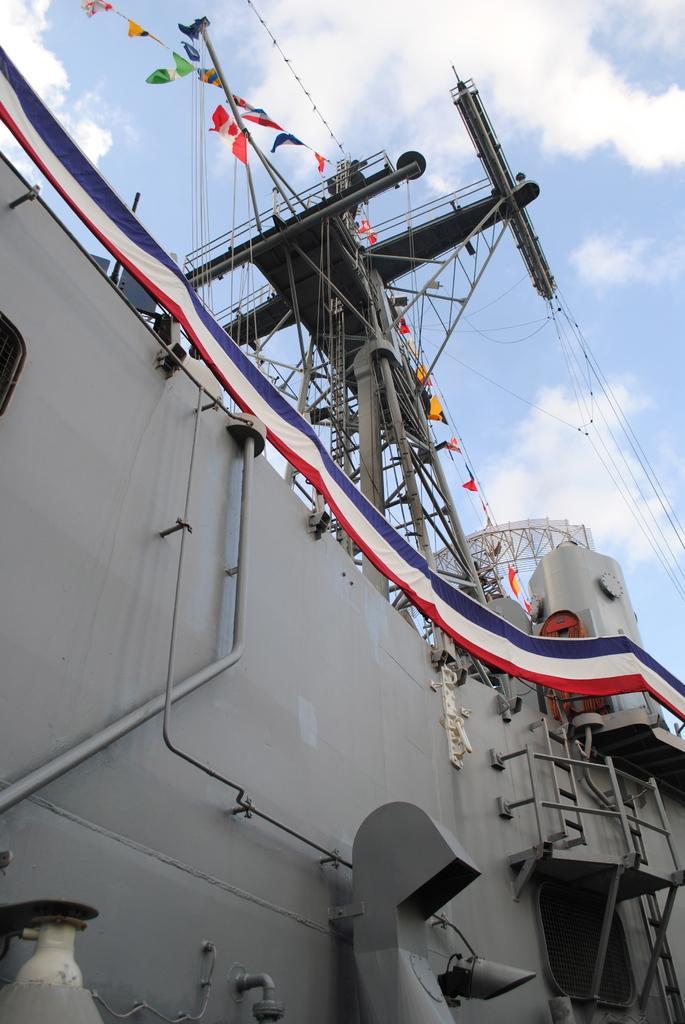Describe this image in one or two sentences. In this picture, we see a crane vessel or a crane ship. It is in white color. We see a banner in white, red and blue color. At the top, we see the sky and the clouds. We see flags in white, red, blue, green and yellow color. 